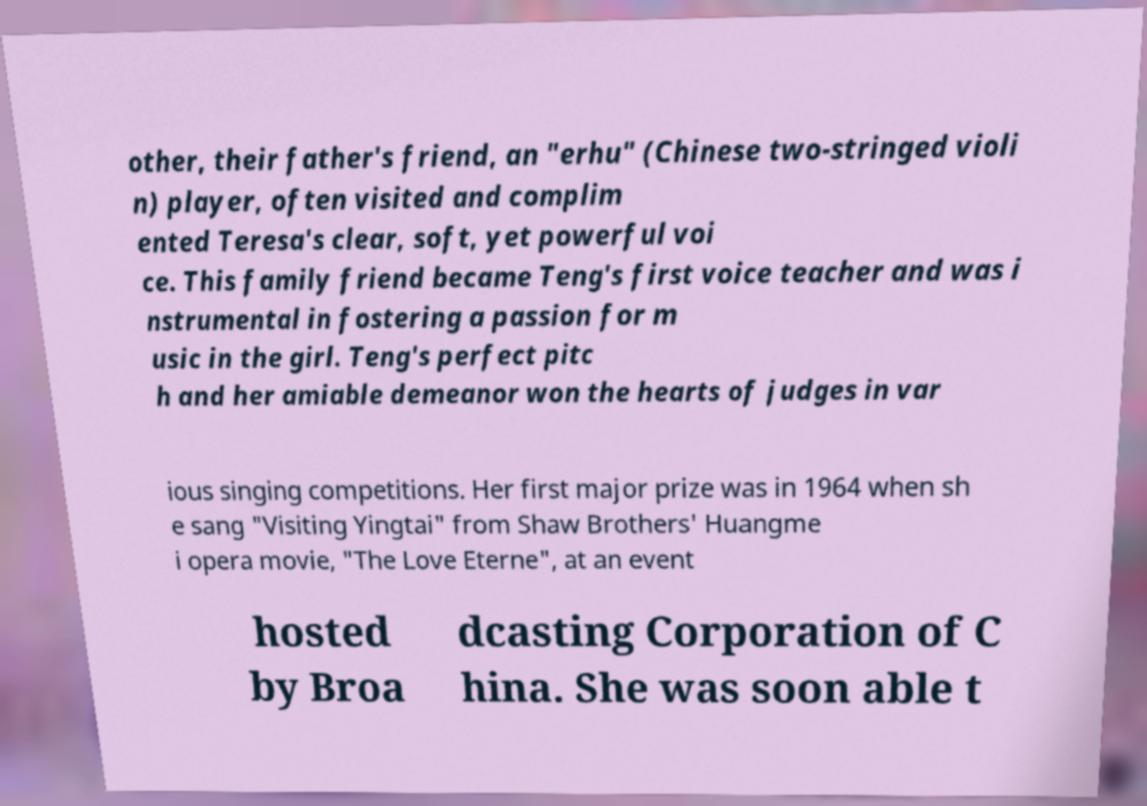There's text embedded in this image that I need extracted. Can you transcribe it verbatim? other, their father's friend, an "erhu" (Chinese two-stringed violi n) player, often visited and complim ented Teresa's clear, soft, yet powerful voi ce. This family friend became Teng's first voice teacher and was i nstrumental in fostering a passion for m usic in the girl. Teng's perfect pitc h and her amiable demeanor won the hearts of judges in var ious singing competitions. Her first major prize was in 1964 when sh e sang "Visiting Yingtai" from Shaw Brothers' Huangme i opera movie, "The Love Eterne", at an event hosted by Broa dcasting Corporation of C hina. She was soon able t 